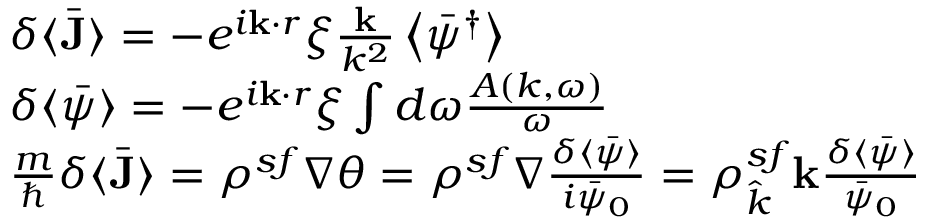Convert formula to latex. <formula><loc_0><loc_0><loc_500><loc_500>\begin{array} { r l } & { \delta \langle \bar { J } \rangle = - e ^ { i k \cdot r } \xi \frac { k } { k ^ { 2 } } \left \langle \bar { \psi } ^ { \dagger } \right \rangle } \\ & { \delta \langle \bar { \psi } \rangle = - e ^ { i k \cdot r } \xi \int d \omega \frac { A ( k , \omega ) } { \omega } } \\ & { \frac { m } { } \delta \langle \bar { J } \rangle = \rho ^ { s f } \nabla \theta = \rho ^ { s f } \nabla \frac { \delta \langle \bar { \psi } \rangle } { i \bar { \psi } _ { 0 } } = \rho _ { \hat { k } } ^ { s f } k \frac { \delta \langle \bar { \psi } \rangle } { \bar { \psi } _ { 0 } } } \end{array}</formula> 